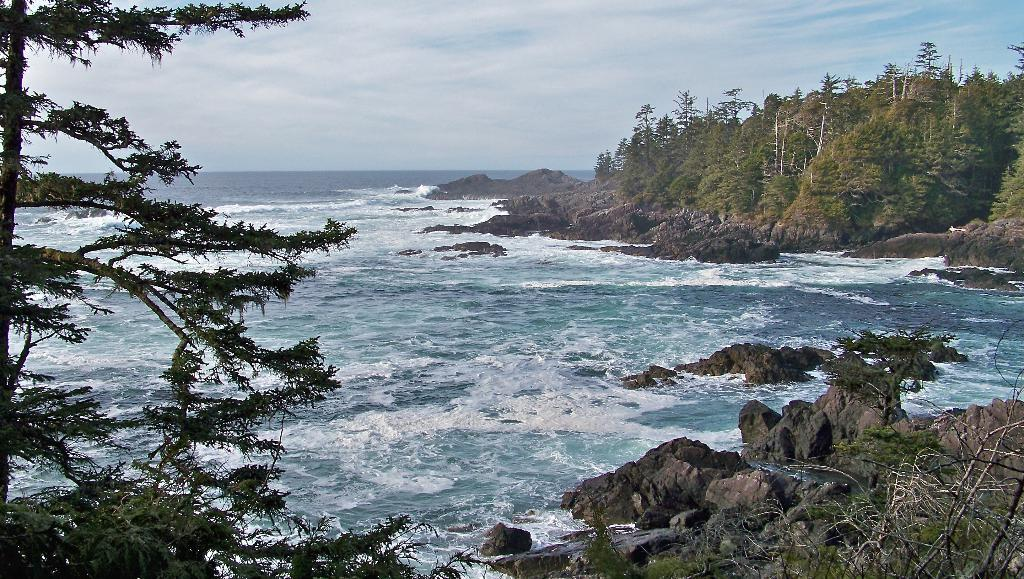What type of vegetation can be seen in the image? There are trees in the image. What natural element is visible besides the trees? There is water visible in the image. What part of the natural environment is visible in the image? The sky is visible in the image. Where is the beggar sitting in the image? There is no beggar present in the image. What type of base is supporting the trees in the image? The trees are not depicted as being supported by a base in the image. 